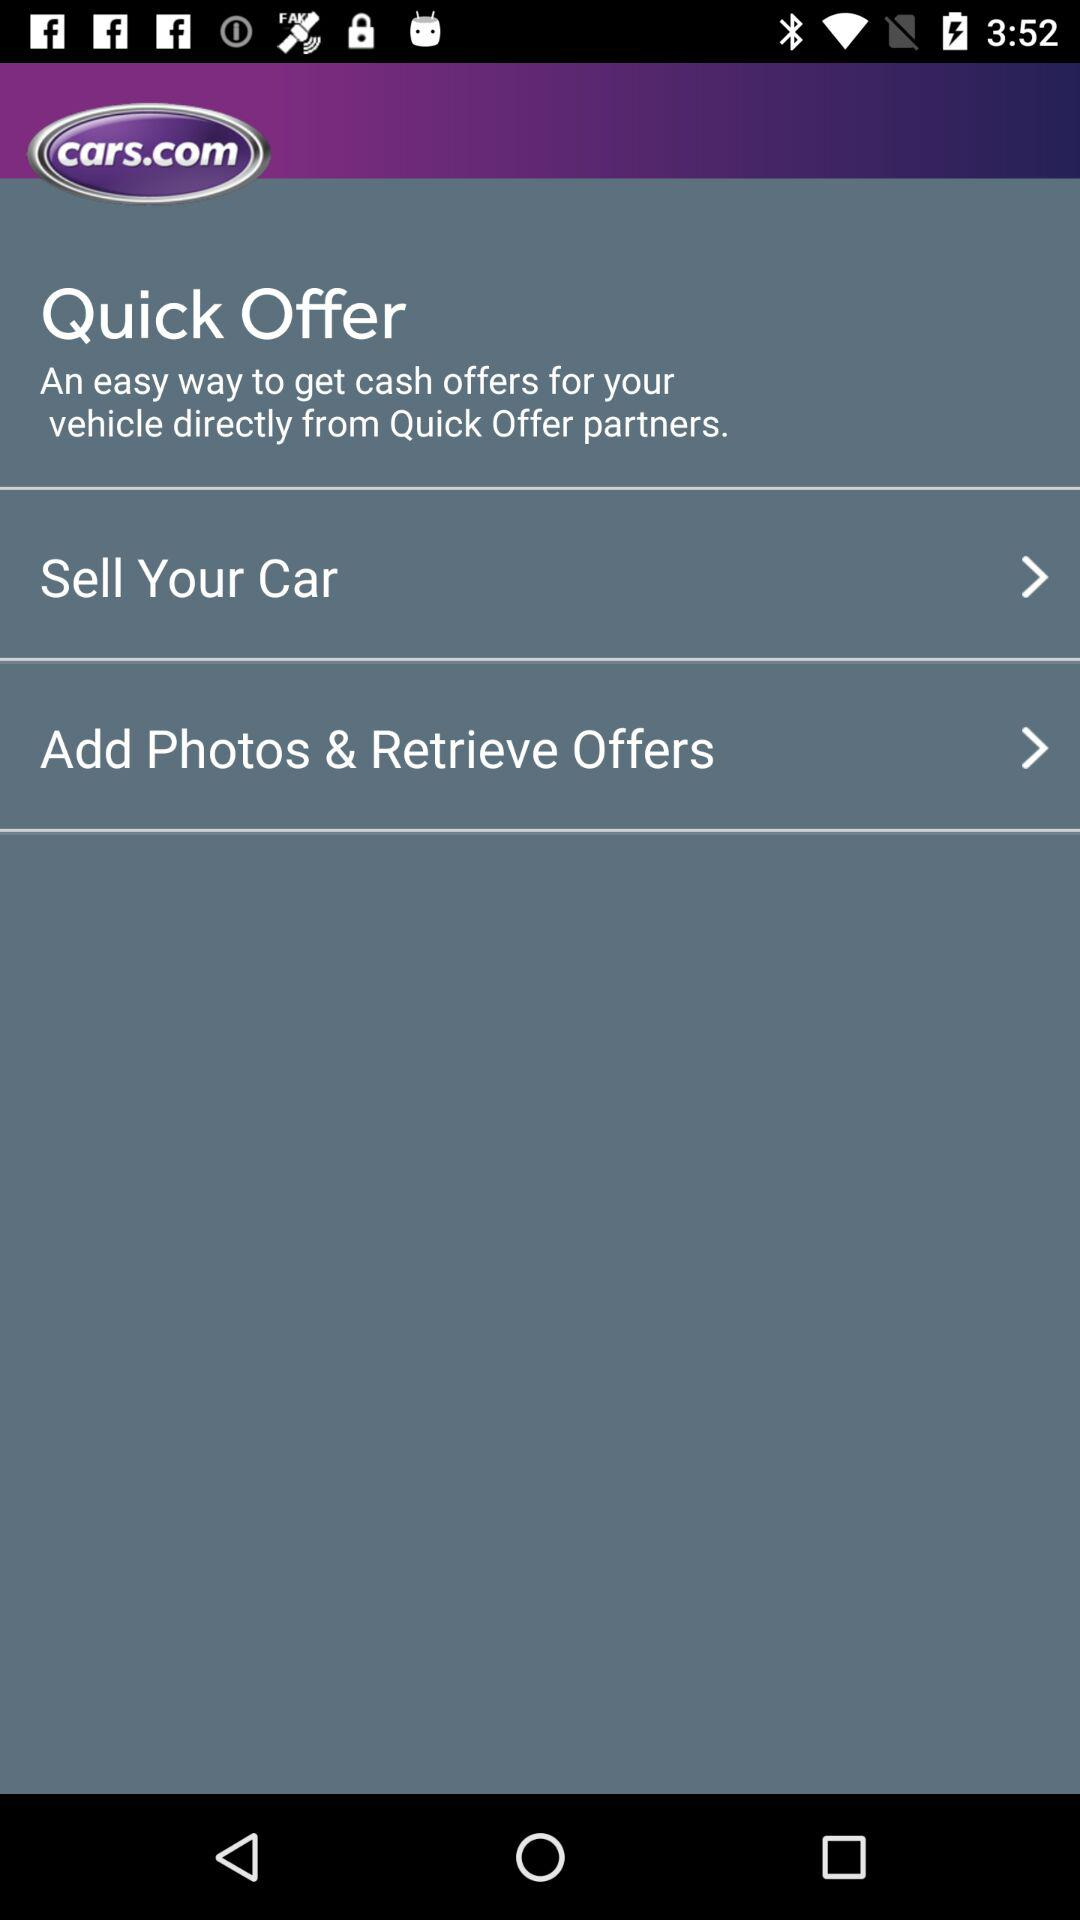How many steps are there in the process of selling your car through Quick Offer?
Answer the question using a single word or phrase. 2 